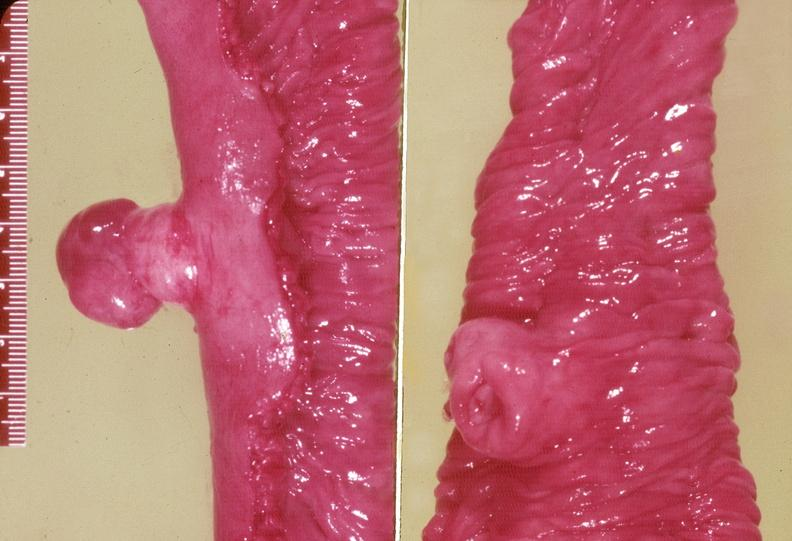where does this belong to?
Answer the question using a single word or phrase. Gastrointestinal system 